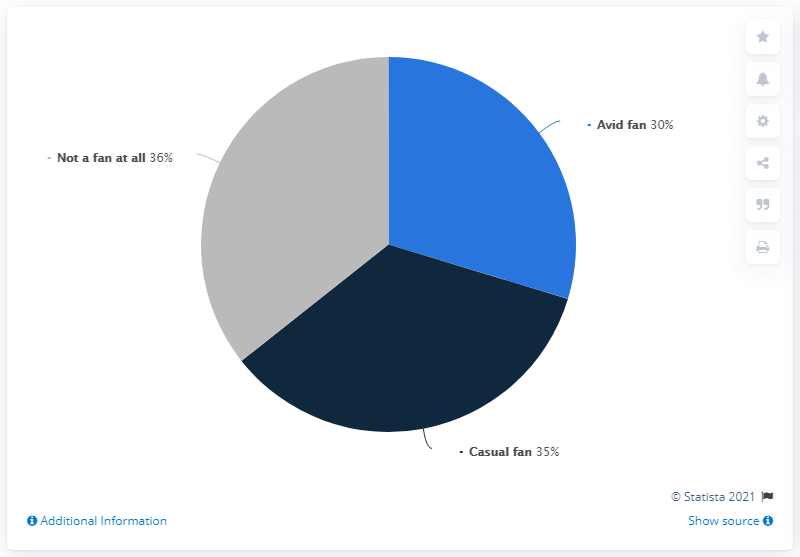List a handful of essential elements in this visual. The interest of an avid fan is 30%. The difference between being a 'not a fan at all' and an 'avid fan' is substantial, with an avid fan being much more passionate and dedicated to the subject. 